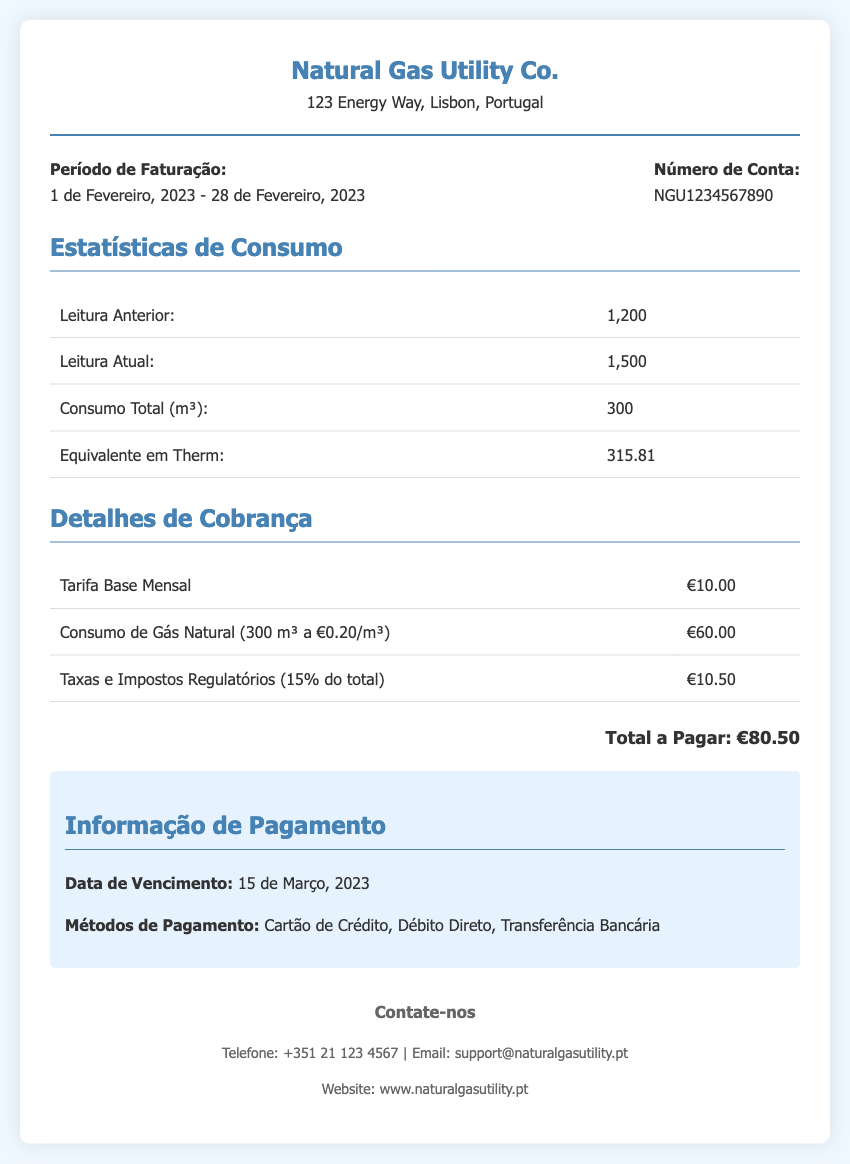What is the billing period? The billing period is listed in the document under "Período de Faturação," specifying the dates covered by the bill.
Answer: 1 de Fevereiro, 2023 - 28 de Fevereiro, 2023 What is the consumption in cubic meters? The total consumption is mentioned in the "Estatísticas de Consumo" section as the total usage for the month.
Answer: 300 What is the account number? The account number is provided in the "Número de Conta" section of the bill.
Answer: NGU1234567890 What is the total amount payable? The total amount payable is specified in the "Detalhes de Cobrança" section, below the billing details.
Answer: €80.50 What is the due date for payment? The due date is described in the "Informação de Pagamento" section of the document.
Answer: 15 de Março, 2023 How much is the base tariff charge? The base tariff charge is detailed in the "Detalhes de Cobrança" section of the bill.
Answer: €10.00 What is the tax percentage applied to the total? The tax percentage is referenced among the charges in the "Detalhes de Cobrança" section, indicating the regulatory fees.
Answer: 15% What is the equivalent consumption in Therms? The equivalent in Therms is noted in the "Estatísticas de Consumo" section, comparing gas volume to energy units.
Answer: 315.81 What methods of payment are available? The payment methods are outlined in the "Informação de Pagamento" section, listing available options for settling the bill.
Answer: Cartão de Crédito, Débito Direto, Transferência Bancária 